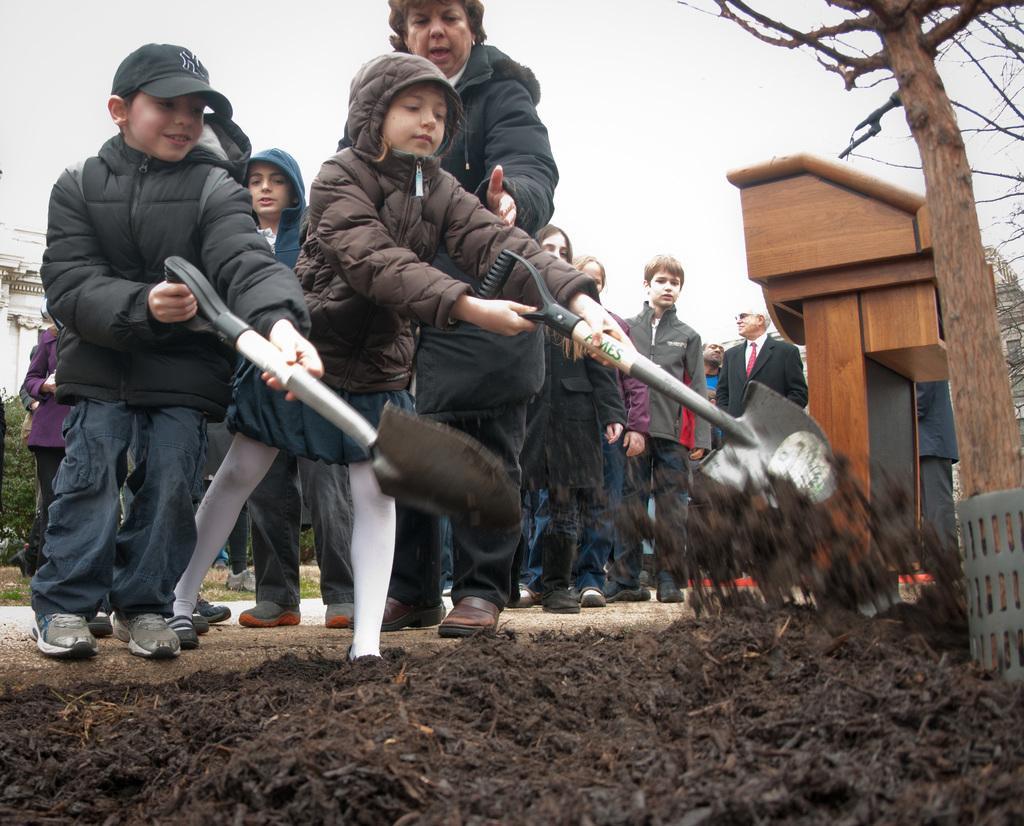Can you describe this image briefly? In this picture I can observe children and some people. They are wearing hoodies. On the right side there is a tree. In the background I can observe sky. 